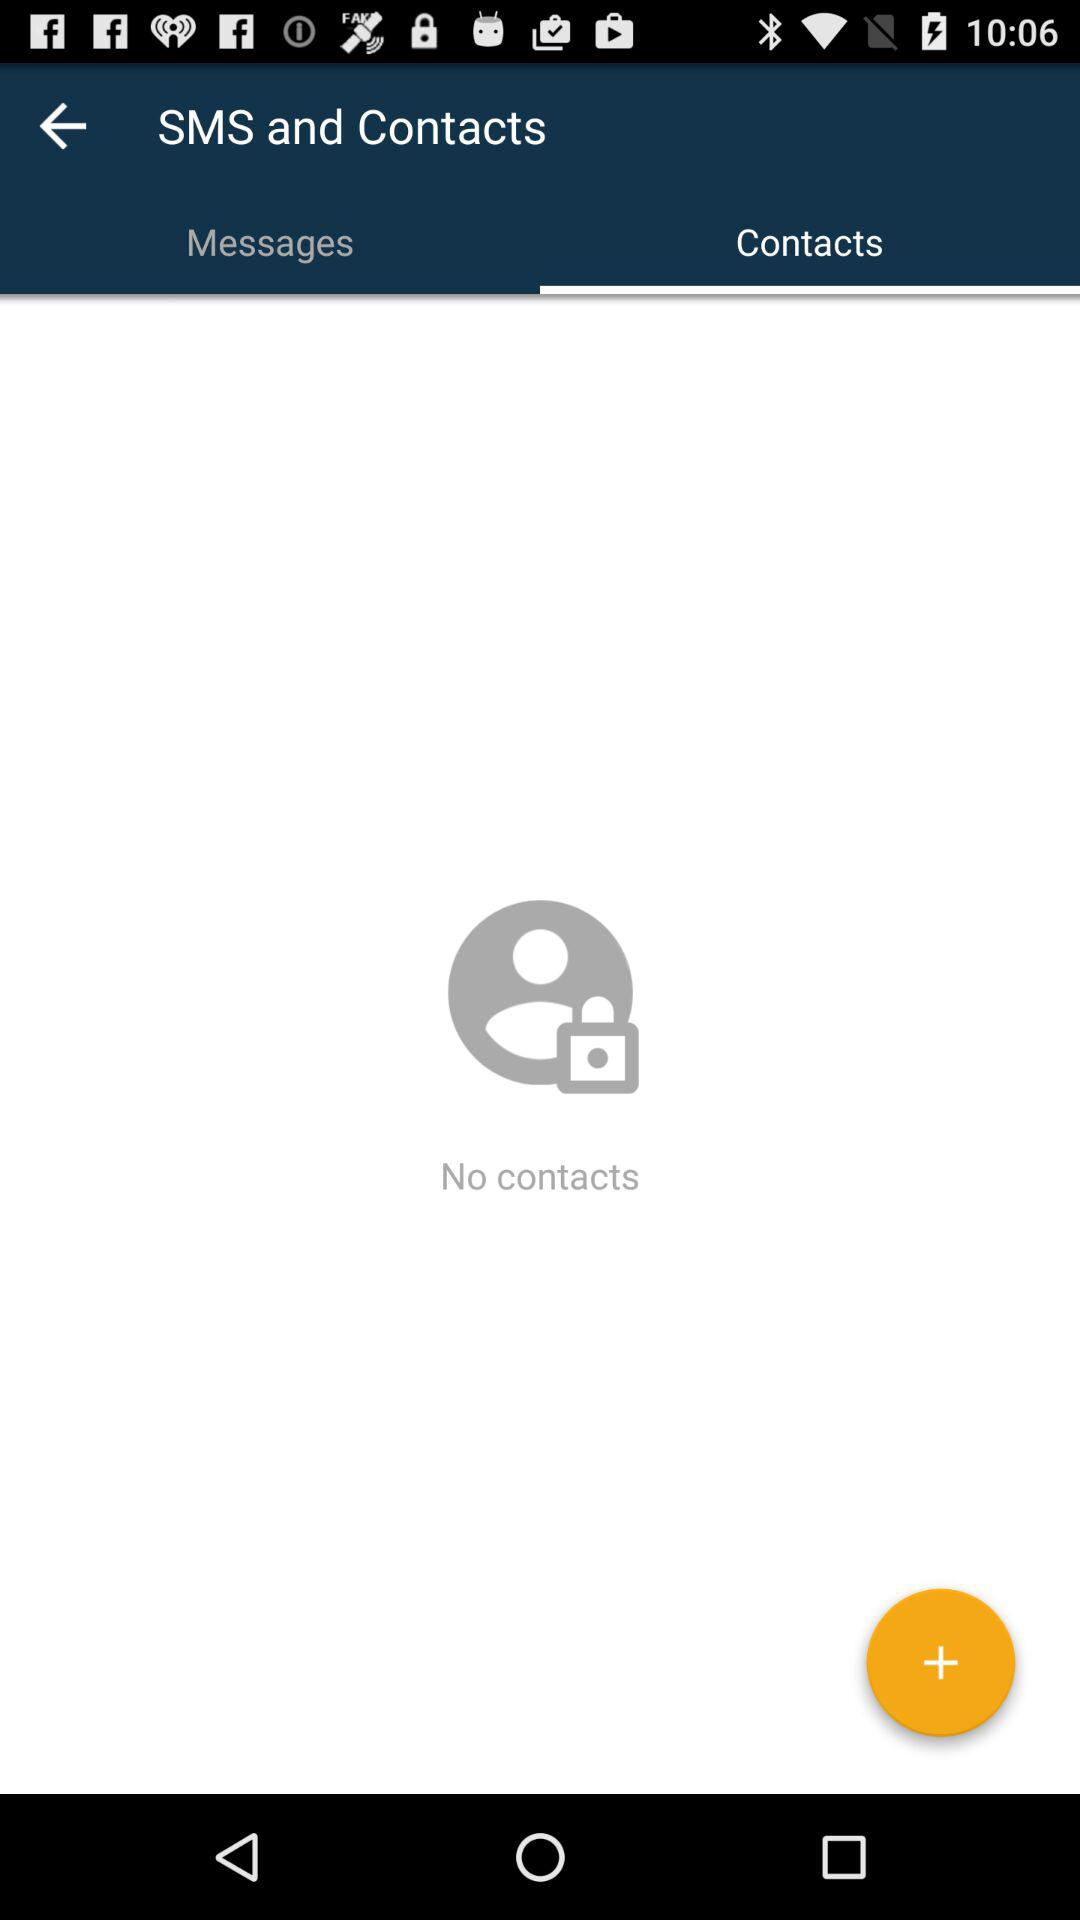Which tab is selected? The selected tab is "Contacts". 